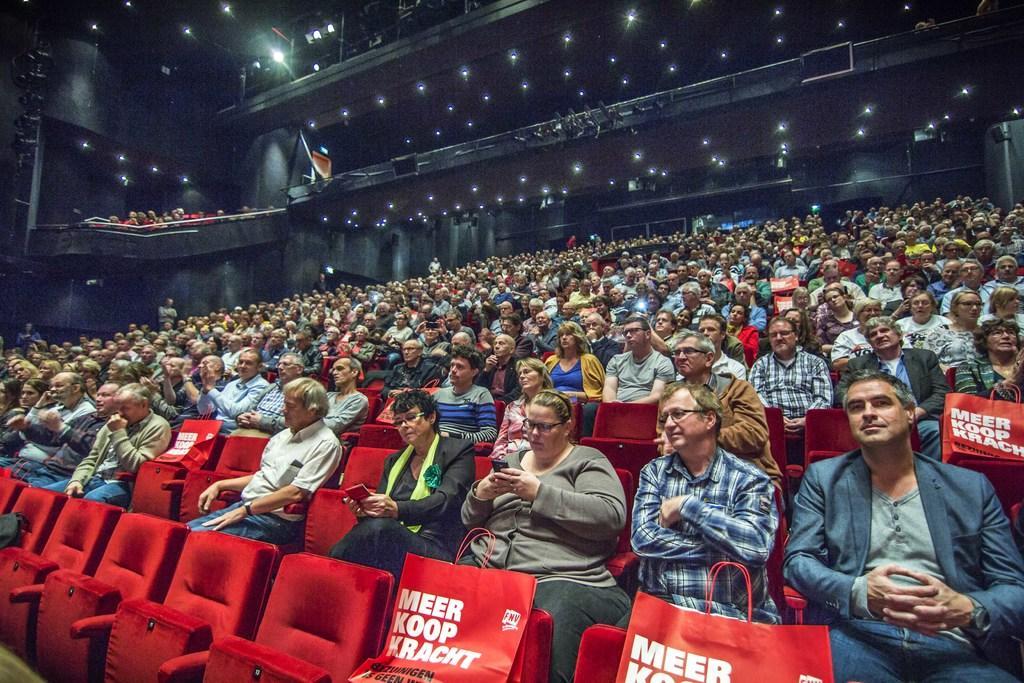Please provide a concise description of this image. In the foreground I can see a crow is sitting on the chairs and bags. In the background I can see lights on a rooftop, group of people are standing, fence and metal objects. This image is taken may be in a stadium. 